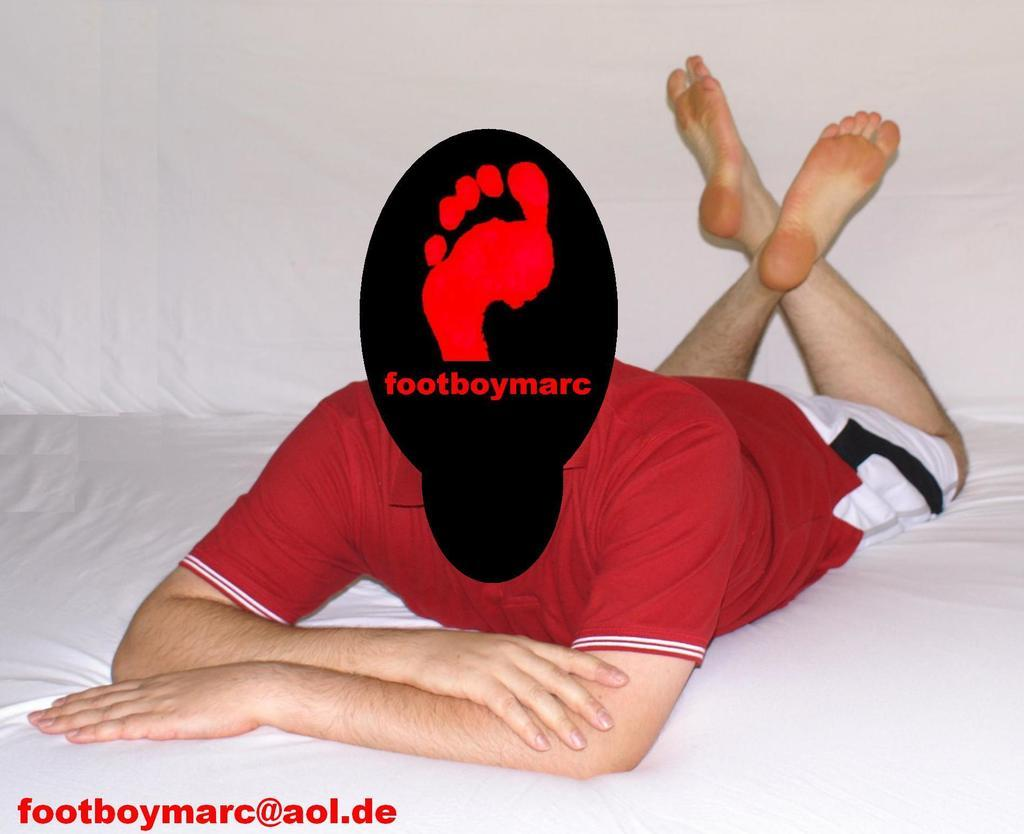<image>
Give a short and clear explanation of the subsequent image. A person poses with their face blacked out with the text, footboymarc. 